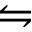Convert formula to latex. <formula><loc_0><loc_0><loc_500><loc_500>\leftrightharpoons</formula> 